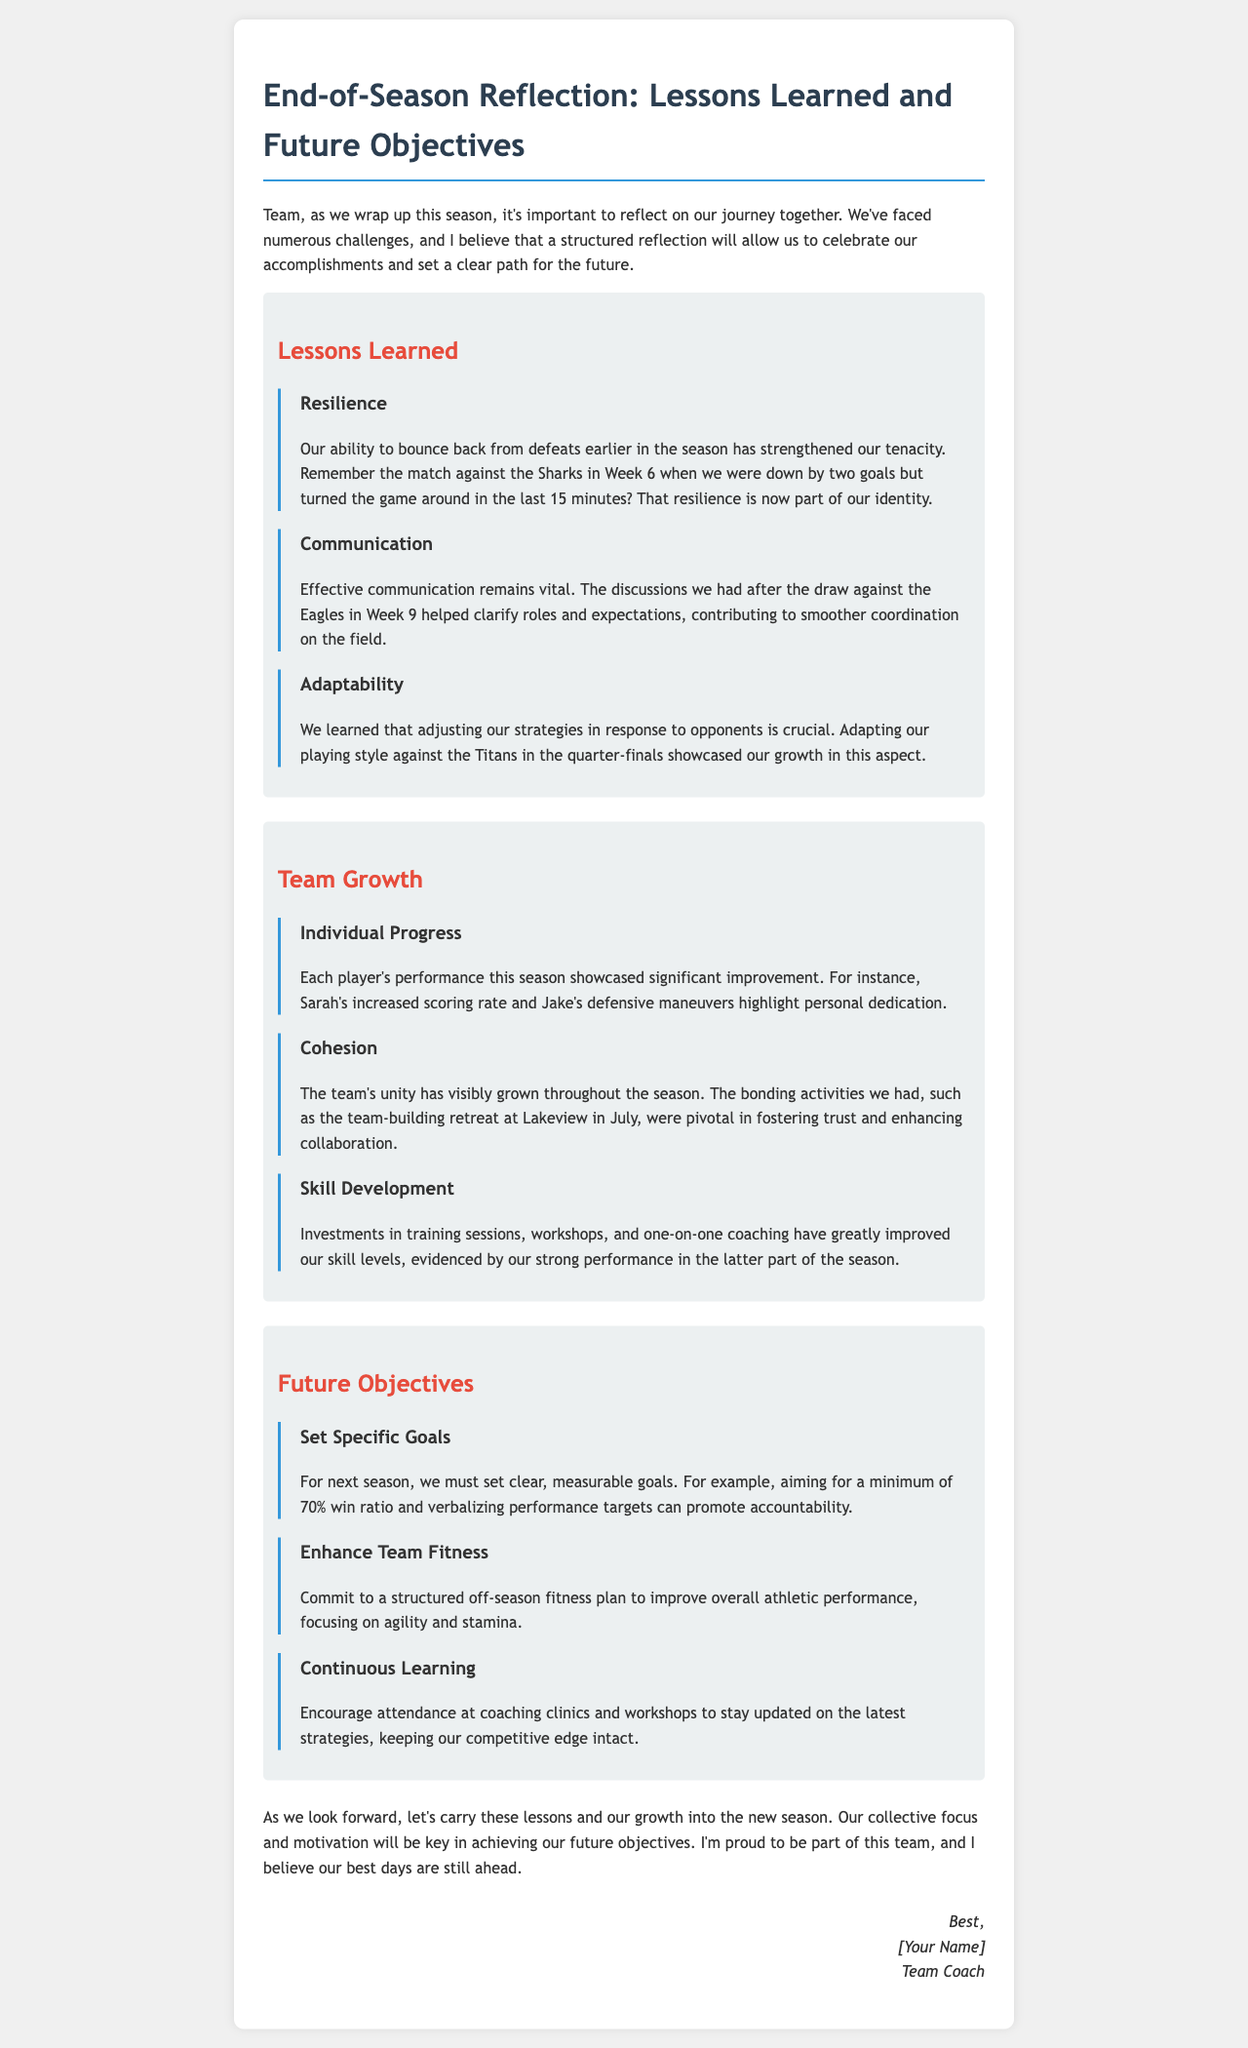What is the title of the document? The title of the document is stated at the beginning and is "End-of-Season Reflection: Lessons Learned and Future Objectives."
Answer: End-of-Season Reflection: Lessons Learned and Future Objectives In which week did the team turn around the game against the Sharks? The document notes that this comeback happened in Week 6.
Answer: Week 6 What is one of the vital lessons highlighted in the communication section? The document emphasizes that "Effective communication remains vital."
Answer: Effective communication What specific objective regarding win ratio is mentioned for the next season? The goal specified for next season is a "minimum of 70% win ratio."
Answer: minimum of 70% win ratio What bonding activity is mentioned in relation to team cohesion? The team-building retreat at Lakeview in July is mentioned as pivotal for fostering collaboration.
Answer: team-building retreat at Lakeview in July How does the document suggest enhancing team fitness? The suggestion for enhancing team fitness involves "a structured off-season fitness plan."
Answer: a structured off-season fitness plan 